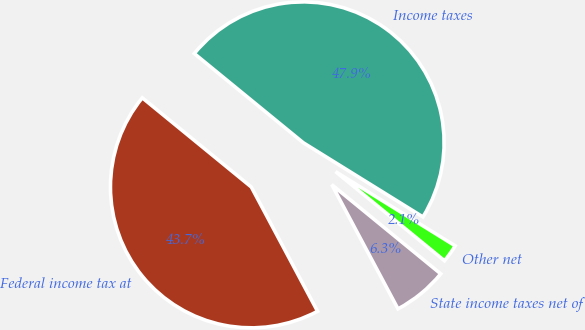Convert chart to OTSL. <chart><loc_0><loc_0><loc_500><loc_500><pie_chart><fcel>Federal income tax at<fcel>State income taxes net of<fcel>Other net<fcel>Income taxes<nl><fcel>43.71%<fcel>6.29%<fcel>2.08%<fcel>47.92%<nl></chart> 